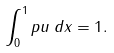<formula> <loc_0><loc_0><loc_500><loc_500>\int _ { 0 } ^ { 1 } p u \, d x = 1 .</formula> 